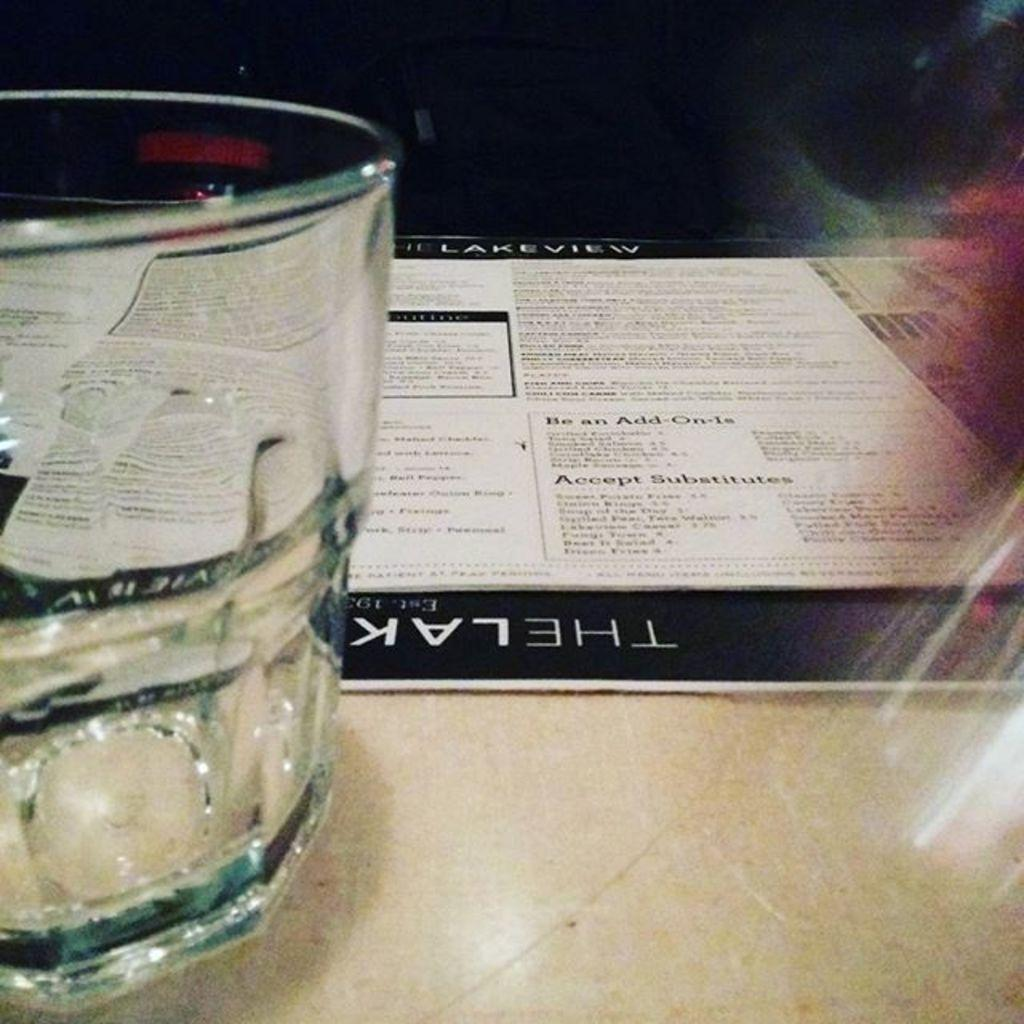Provide a one-sentence caption for the provided image. An empty tumbler in front of a menu for the Lakeview that is laying on a table. 